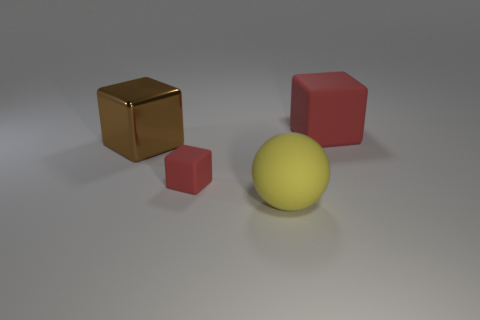Add 3 big rubber balls. How many objects exist? 7 Subtract all blocks. How many objects are left? 1 Add 2 yellow balls. How many yellow balls are left? 3 Add 1 large things. How many large things exist? 4 Subtract 0 green cylinders. How many objects are left? 4 Subtract all big shiny blocks. Subtract all red blocks. How many objects are left? 1 